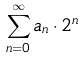<formula> <loc_0><loc_0><loc_500><loc_500>\sum _ { n = 0 } ^ { \infty } a _ { n } \cdot 2 ^ { n }</formula> 